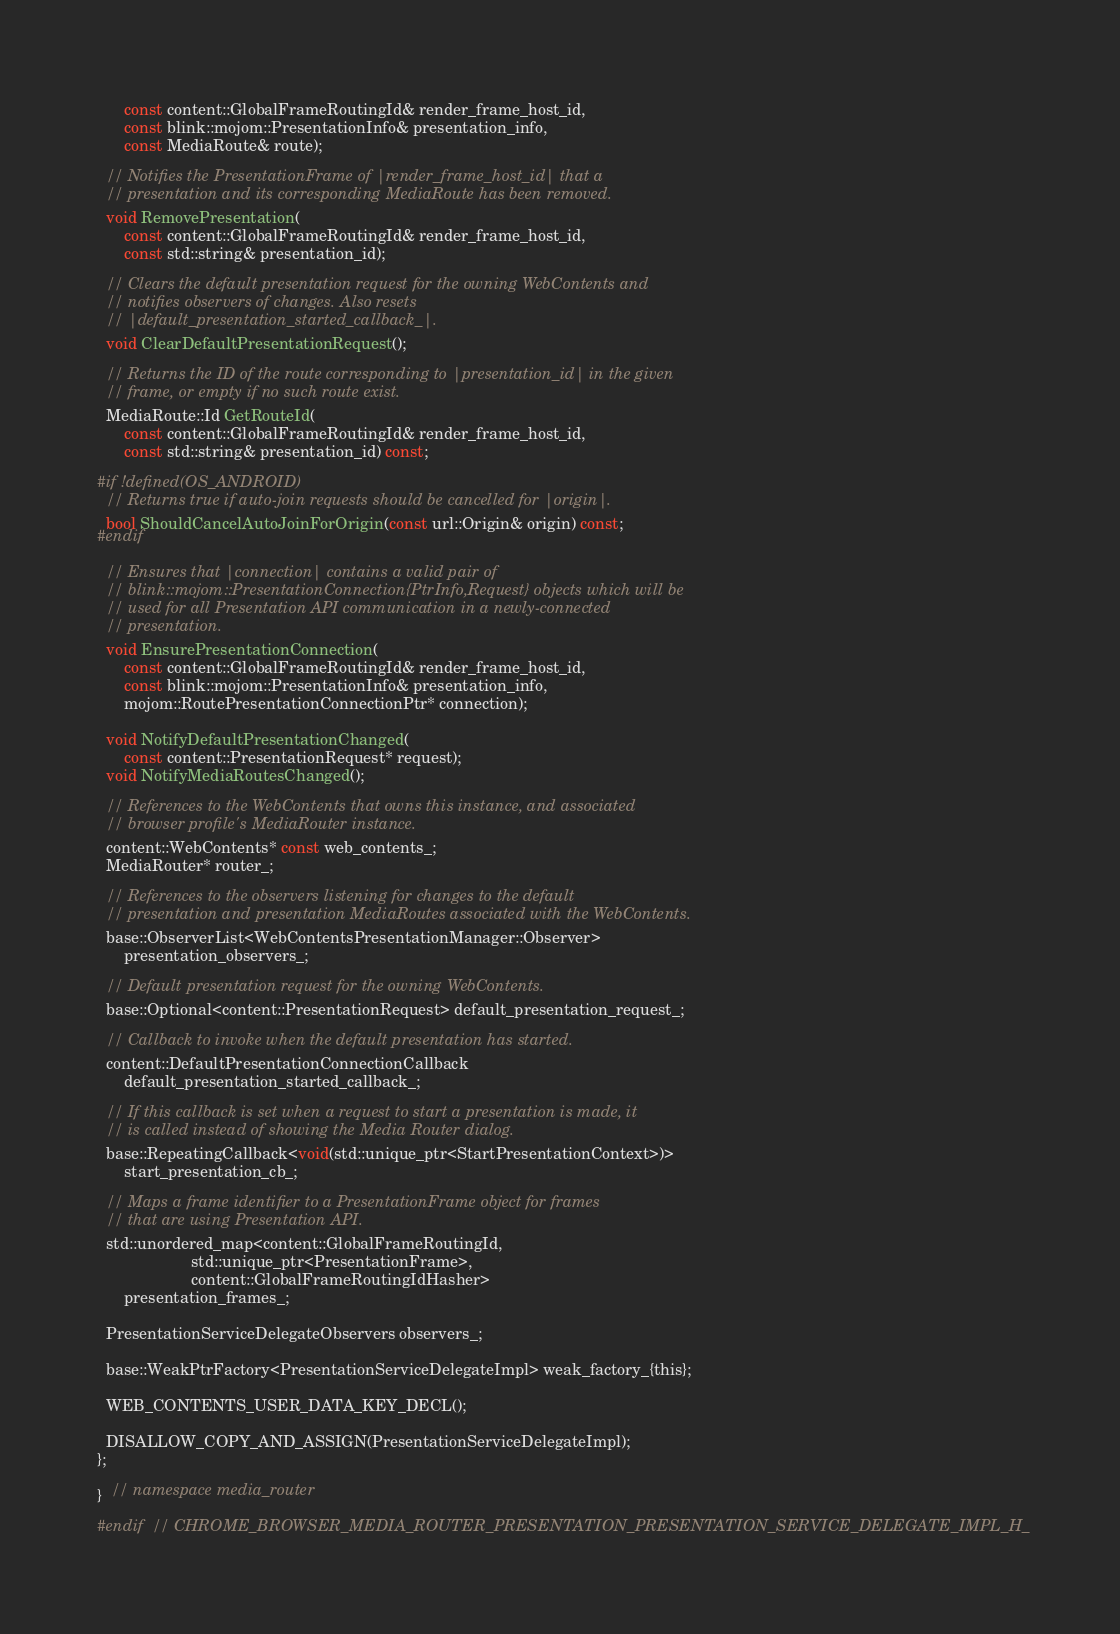Convert code to text. <code><loc_0><loc_0><loc_500><loc_500><_C_>      const content::GlobalFrameRoutingId& render_frame_host_id,
      const blink::mojom::PresentationInfo& presentation_info,
      const MediaRoute& route);

  // Notifies the PresentationFrame of |render_frame_host_id| that a
  // presentation and its corresponding MediaRoute has been removed.
  void RemovePresentation(
      const content::GlobalFrameRoutingId& render_frame_host_id,
      const std::string& presentation_id);

  // Clears the default presentation request for the owning WebContents and
  // notifies observers of changes. Also resets
  // |default_presentation_started_callback_|.
  void ClearDefaultPresentationRequest();

  // Returns the ID of the route corresponding to |presentation_id| in the given
  // frame, or empty if no such route exist.
  MediaRoute::Id GetRouteId(
      const content::GlobalFrameRoutingId& render_frame_host_id,
      const std::string& presentation_id) const;

#if !defined(OS_ANDROID)
  // Returns true if auto-join requests should be cancelled for |origin|.
  bool ShouldCancelAutoJoinForOrigin(const url::Origin& origin) const;
#endif

  // Ensures that |connection| contains a valid pair of
  // blink::mojom::PresentationConnection{PtrInfo,Request} objects which will be
  // used for all Presentation API communication in a newly-connected
  // presentation.
  void EnsurePresentationConnection(
      const content::GlobalFrameRoutingId& render_frame_host_id,
      const blink::mojom::PresentationInfo& presentation_info,
      mojom::RoutePresentationConnectionPtr* connection);

  void NotifyDefaultPresentationChanged(
      const content::PresentationRequest* request);
  void NotifyMediaRoutesChanged();

  // References to the WebContents that owns this instance, and associated
  // browser profile's MediaRouter instance.
  content::WebContents* const web_contents_;
  MediaRouter* router_;

  // References to the observers listening for changes to the default
  // presentation and presentation MediaRoutes associated with the WebContents.
  base::ObserverList<WebContentsPresentationManager::Observer>
      presentation_observers_;

  // Default presentation request for the owning WebContents.
  base::Optional<content::PresentationRequest> default_presentation_request_;

  // Callback to invoke when the default presentation has started.
  content::DefaultPresentationConnectionCallback
      default_presentation_started_callback_;

  // If this callback is set when a request to start a presentation is made, it
  // is called instead of showing the Media Router dialog.
  base::RepeatingCallback<void(std::unique_ptr<StartPresentationContext>)>
      start_presentation_cb_;

  // Maps a frame identifier to a PresentationFrame object for frames
  // that are using Presentation API.
  std::unordered_map<content::GlobalFrameRoutingId,
                     std::unique_ptr<PresentationFrame>,
                     content::GlobalFrameRoutingIdHasher>
      presentation_frames_;

  PresentationServiceDelegateObservers observers_;

  base::WeakPtrFactory<PresentationServiceDelegateImpl> weak_factory_{this};

  WEB_CONTENTS_USER_DATA_KEY_DECL();

  DISALLOW_COPY_AND_ASSIGN(PresentationServiceDelegateImpl);
};

}  // namespace media_router

#endif  // CHROME_BROWSER_MEDIA_ROUTER_PRESENTATION_PRESENTATION_SERVICE_DELEGATE_IMPL_H_
</code> 